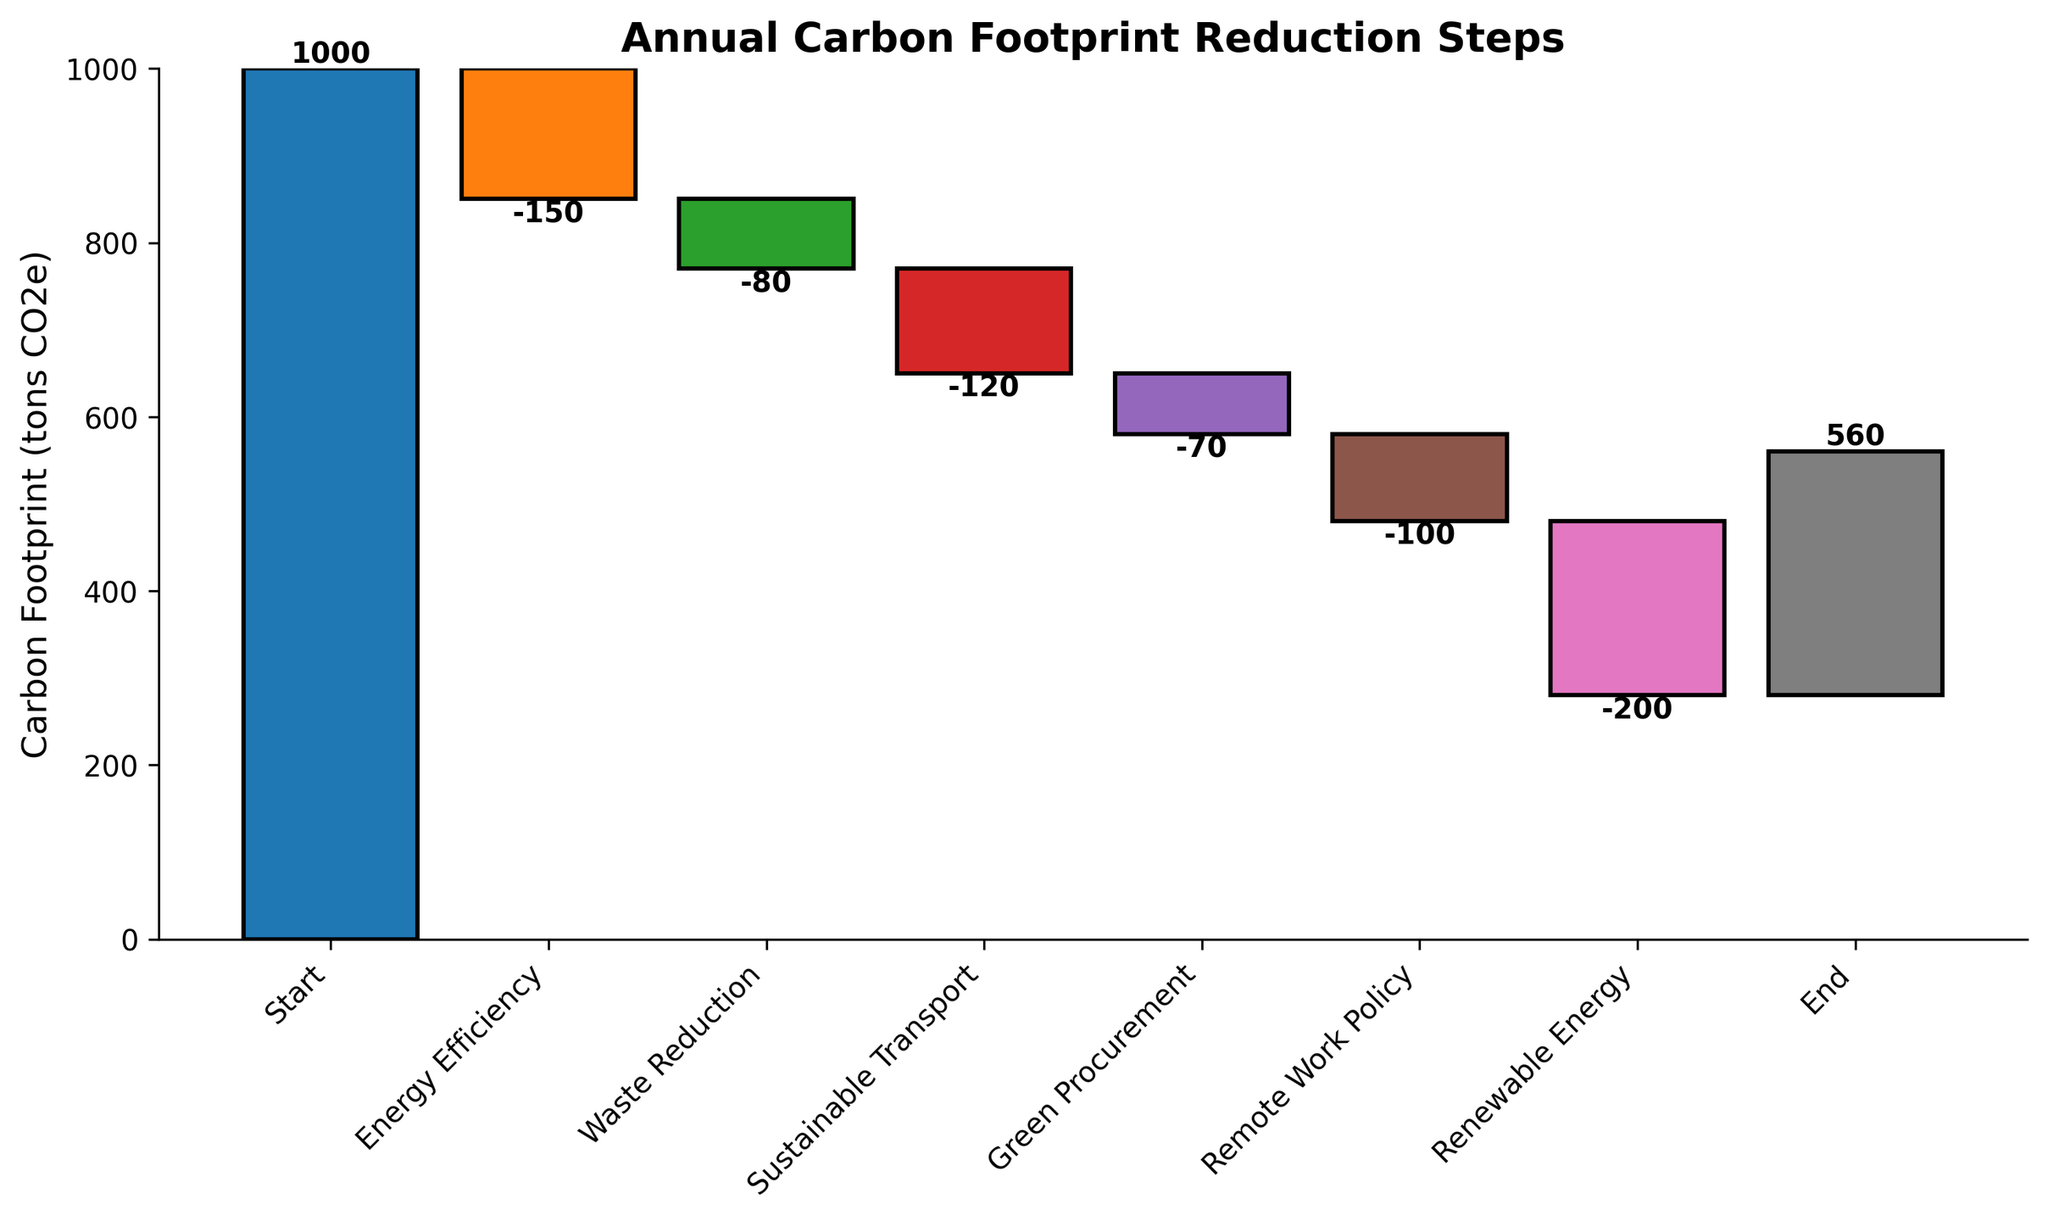What is the title of the figure? The title of the figure is located at the top and reads "Annual Carbon Footprint Reduction Steps."
Answer: Annual Carbon Footprint Reduction Steps How many steps are illustrated in the figure? The x-axis labels represent steps, and they are "Start," "Energy Efficiency," "Waste Reduction," "Sustainable Transport," "Green Procurement," "Remote Work Policy," "Renewable Energy," and "End."
Answer: 8 What is the value of the carbon footprint reduction due to Renewable Energy? The bar representing "Renewable Energy" shows a value of -200, which indicates a reduction.
Answer: -200 What is the final carbon footprint value at the end? The last step bar labeled "End" shows the value, which is 280.
Answer: 280 Which step contributed the most to reducing the carbon footprint? By examining the bar heights, the "Renewable Energy" step has the largest negative value, indicating the most significant reduction at -200.
Answer: Renewable Energy What is the cumulative reduction after applying Energy Efficiency and Waste Reduction? Starting from the original 1000, we subtract -150 for Energy Efficiency and -80 for Waste Reduction, resulting in 1000 - 150 - 80.
Answer: 770 How much more effective is Sustainable Transport compared to Green Procurement in reducing the carbon footprint? Sustainable Transport reduces by -120, while Green Procurement reduces by -70. The difference is -120 - (-70).
Answer: 50 What is the average reduction value for all reduction steps except the start and end? The values for reduction steps are -150, -80, -120, -70, -100, -200. Sum these values and divide by the number of steps (6).
Answer: -120 What was the carbon footprint before any reductions were applied? The "Start" bar at the beginning shows the initial value, which is 1000.
Answer: 1000 How much carbon footprint reduction is achieved by Remote Work Policy relative to the initial footprint? Remote Work Policy reduces by -100; relative reduction is (-100 / 1000) * 100%.
Answer: 10% 